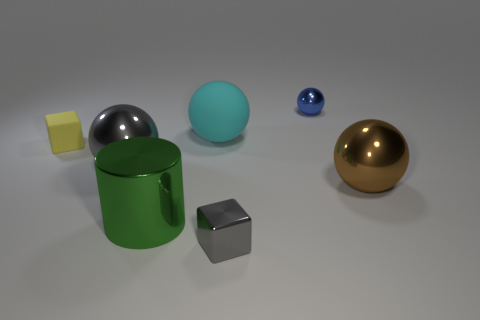Add 2 tiny yellow cylinders. How many objects exist? 9 Subtract all gray spheres. How many spheres are left? 3 Subtract 2 balls. How many balls are left? 2 Subtract all gray spheres. How many spheres are left? 3 Subtract all cylinders. How many objects are left? 6 Add 6 large red matte things. How many large red matte things exist? 6 Subtract 0 red cylinders. How many objects are left? 7 Subtract all gray spheres. Subtract all brown cylinders. How many spheres are left? 3 Subtract all green objects. Subtract all big green cylinders. How many objects are left? 5 Add 3 yellow matte blocks. How many yellow matte blocks are left? 4 